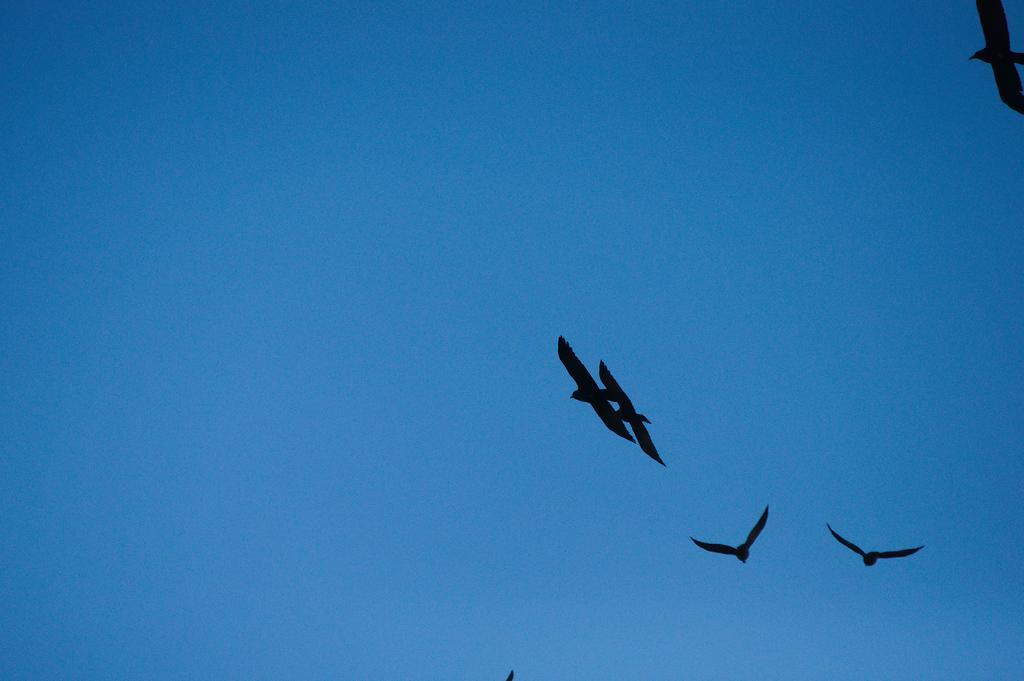How would you summarize this image in a sentence or two? In this picture we can see there are some birds flying in the sky. 